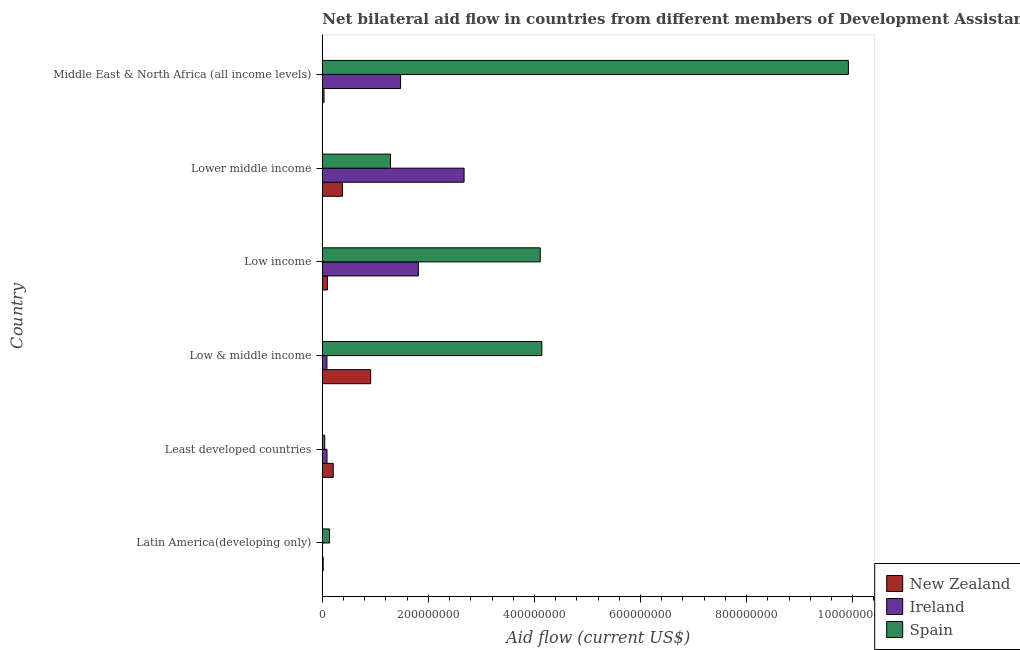How many groups of bars are there?
Offer a terse response. 6. Are the number of bars on each tick of the Y-axis equal?
Give a very brief answer. Yes. What is the label of the 1st group of bars from the top?
Your answer should be compact. Middle East & North Africa (all income levels). What is the amount of aid provided by new zealand in Latin America(developing only)?
Provide a succinct answer. 1.61e+06. Across all countries, what is the maximum amount of aid provided by spain?
Ensure brevity in your answer.  9.92e+08. Across all countries, what is the minimum amount of aid provided by new zealand?
Ensure brevity in your answer.  1.61e+06. In which country was the amount of aid provided by ireland minimum?
Provide a short and direct response. Latin America(developing only). What is the total amount of aid provided by new zealand in the graph?
Your answer should be very brief. 1.64e+08. What is the difference between the amount of aid provided by spain in Latin America(developing only) and that in Low & middle income?
Keep it short and to the point. -4.00e+08. What is the difference between the amount of aid provided by spain in Low & middle income and the amount of aid provided by new zealand in Least developed countries?
Make the answer very short. 3.93e+08. What is the average amount of aid provided by ireland per country?
Keep it short and to the point. 1.02e+08. What is the difference between the amount of aid provided by ireland and amount of aid provided by new zealand in Latin America(developing only)?
Ensure brevity in your answer.  -1.24e+06. In how many countries, is the amount of aid provided by new zealand greater than 800000000 US$?
Provide a succinct answer. 0. What is the ratio of the amount of aid provided by spain in Latin America(developing only) to that in Low income?
Provide a succinct answer. 0.03. Is the amount of aid provided by ireland in Latin America(developing only) less than that in Lower middle income?
Ensure brevity in your answer.  Yes. Is the difference between the amount of aid provided by new zealand in Low income and Middle East & North Africa (all income levels) greater than the difference between the amount of aid provided by ireland in Low income and Middle East & North Africa (all income levels)?
Your answer should be very brief. No. What is the difference between the highest and the second highest amount of aid provided by new zealand?
Make the answer very short. 5.33e+07. What is the difference between the highest and the lowest amount of aid provided by new zealand?
Give a very brief answer. 8.96e+07. In how many countries, is the amount of aid provided by new zealand greater than the average amount of aid provided by new zealand taken over all countries?
Provide a succinct answer. 2. What does the 1st bar from the top in Latin America(developing only) represents?
Make the answer very short. Spain. What does the 3rd bar from the bottom in Latin America(developing only) represents?
Make the answer very short. Spain. How many bars are there?
Make the answer very short. 18. Are all the bars in the graph horizontal?
Your response must be concise. Yes. How many countries are there in the graph?
Your response must be concise. 6. What is the difference between two consecutive major ticks on the X-axis?
Your answer should be compact. 2.00e+08. Are the values on the major ticks of X-axis written in scientific E-notation?
Your answer should be very brief. No. Does the graph contain any zero values?
Your answer should be compact. No. Does the graph contain grids?
Provide a short and direct response. No. How are the legend labels stacked?
Provide a short and direct response. Vertical. What is the title of the graph?
Your answer should be compact. Net bilateral aid flow in countries from different members of Development Assistance Committee. Does "Ages 65 and above" appear as one of the legend labels in the graph?
Make the answer very short. No. What is the Aid flow (current US$) of New Zealand in Latin America(developing only)?
Provide a succinct answer. 1.61e+06. What is the Aid flow (current US$) in Ireland in Latin America(developing only)?
Offer a very short reply. 3.70e+05. What is the Aid flow (current US$) in Spain in Latin America(developing only)?
Provide a succinct answer. 1.36e+07. What is the Aid flow (current US$) in New Zealand in Least developed countries?
Offer a terse response. 2.06e+07. What is the Aid flow (current US$) of Ireland in Least developed countries?
Offer a very short reply. 8.82e+06. What is the Aid flow (current US$) in Spain in Least developed countries?
Provide a succinct answer. 4.51e+06. What is the Aid flow (current US$) in New Zealand in Low & middle income?
Ensure brevity in your answer.  9.12e+07. What is the Aid flow (current US$) in Ireland in Low & middle income?
Offer a very short reply. 8.66e+06. What is the Aid flow (current US$) of Spain in Low & middle income?
Provide a succinct answer. 4.14e+08. What is the Aid flow (current US$) in New Zealand in Low income?
Offer a very short reply. 9.64e+06. What is the Aid flow (current US$) of Ireland in Low income?
Give a very brief answer. 1.81e+08. What is the Aid flow (current US$) of Spain in Low income?
Give a very brief answer. 4.11e+08. What is the Aid flow (current US$) of New Zealand in Lower middle income?
Ensure brevity in your answer.  3.79e+07. What is the Aid flow (current US$) of Ireland in Lower middle income?
Provide a succinct answer. 2.67e+08. What is the Aid flow (current US$) in Spain in Lower middle income?
Provide a succinct answer. 1.29e+08. What is the Aid flow (current US$) of New Zealand in Middle East & North Africa (all income levels)?
Offer a very short reply. 3.16e+06. What is the Aid flow (current US$) in Ireland in Middle East & North Africa (all income levels)?
Offer a terse response. 1.48e+08. What is the Aid flow (current US$) in Spain in Middle East & North Africa (all income levels)?
Provide a short and direct response. 9.92e+08. Across all countries, what is the maximum Aid flow (current US$) of New Zealand?
Give a very brief answer. 9.12e+07. Across all countries, what is the maximum Aid flow (current US$) of Ireland?
Your answer should be compact. 2.67e+08. Across all countries, what is the maximum Aid flow (current US$) in Spain?
Offer a terse response. 9.92e+08. Across all countries, what is the minimum Aid flow (current US$) of New Zealand?
Offer a very short reply. 1.61e+06. Across all countries, what is the minimum Aid flow (current US$) in Spain?
Offer a terse response. 4.51e+06. What is the total Aid flow (current US$) in New Zealand in the graph?
Make the answer very short. 1.64e+08. What is the total Aid flow (current US$) of Ireland in the graph?
Ensure brevity in your answer.  6.14e+08. What is the total Aid flow (current US$) in Spain in the graph?
Your answer should be compact. 1.96e+09. What is the difference between the Aid flow (current US$) of New Zealand in Latin America(developing only) and that in Least developed countries?
Your response must be concise. -1.90e+07. What is the difference between the Aid flow (current US$) of Ireland in Latin America(developing only) and that in Least developed countries?
Make the answer very short. -8.45e+06. What is the difference between the Aid flow (current US$) of Spain in Latin America(developing only) and that in Least developed countries?
Your answer should be compact. 9.06e+06. What is the difference between the Aid flow (current US$) in New Zealand in Latin America(developing only) and that in Low & middle income?
Keep it short and to the point. -8.96e+07. What is the difference between the Aid flow (current US$) of Ireland in Latin America(developing only) and that in Low & middle income?
Ensure brevity in your answer.  -8.29e+06. What is the difference between the Aid flow (current US$) in Spain in Latin America(developing only) and that in Low & middle income?
Provide a short and direct response. -4.00e+08. What is the difference between the Aid flow (current US$) in New Zealand in Latin America(developing only) and that in Low income?
Make the answer very short. -8.03e+06. What is the difference between the Aid flow (current US$) in Ireland in Latin America(developing only) and that in Low income?
Offer a very short reply. -1.81e+08. What is the difference between the Aid flow (current US$) in Spain in Latin America(developing only) and that in Low income?
Ensure brevity in your answer.  -3.97e+08. What is the difference between the Aid flow (current US$) of New Zealand in Latin America(developing only) and that in Lower middle income?
Provide a succinct answer. -3.63e+07. What is the difference between the Aid flow (current US$) of Ireland in Latin America(developing only) and that in Lower middle income?
Offer a terse response. -2.67e+08. What is the difference between the Aid flow (current US$) in Spain in Latin America(developing only) and that in Lower middle income?
Keep it short and to the point. -1.15e+08. What is the difference between the Aid flow (current US$) in New Zealand in Latin America(developing only) and that in Middle East & North Africa (all income levels)?
Give a very brief answer. -1.55e+06. What is the difference between the Aid flow (current US$) in Ireland in Latin America(developing only) and that in Middle East & North Africa (all income levels)?
Offer a very short reply. -1.47e+08. What is the difference between the Aid flow (current US$) of Spain in Latin America(developing only) and that in Middle East & North Africa (all income levels)?
Your answer should be very brief. -9.78e+08. What is the difference between the Aid flow (current US$) of New Zealand in Least developed countries and that in Low & middle income?
Your response must be concise. -7.06e+07. What is the difference between the Aid flow (current US$) in Ireland in Least developed countries and that in Low & middle income?
Offer a terse response. 1.60e+05. What is the difference between the Aid flow (current US$) of Spain in Least developed countries and that in Low & middle income?
Give a very brief answer. -4.09e+08. What is the difference between the Aid flow (current US$) in New Zealand in Least developed countries and that in Low income?
Your response must be concise. 1.10e+07. What is the difference between the Aid flow (current US$) in Ireland in Least developed countries and that in Low income?
Your response must be concise. -1.72e+08. What is the difference between the Aid flow (current US$) in Spain in Least developed countries and that in Low income?
Provide a succinct answer. -4.06e+08. What is the difference between the Aid flow (current US$) of New Zealand in Least developed countries and that in Lower middle income?
Provide a short and direct response. -1.73e+07. What is the difference between the Aid flow (current US$) of Ireland in Least developed countries and that in Lower middle income?
Your response must be concise. -2.58e+08. What is the difference between the Aid flow (current US$) in Spain in Least developed countries and that in Lower middle income?
Make the answer very short. -1.24e+08. What is the difference between the Aid flow (current US$) in New Zealand in Least developed countries and that in Middle East & North Africa (all income levels)?
Keep it short and to the point. 1.74e+07. What is the difference between the Aid flow (current US$) of Ireland in Least developed countries and that in Middle East & North Africa (all income levels)?
Your answer should be very brief. -1.39e+08. What is the difference between the Aid flow (current US$) of Spain in Least developed countries and that in Middle East & North Africa (all income levels)?
Ensure brevity in your answer.  -9.87e+08. What is the difference between the Aid flow (current US$) of New Zealand in Low & middle income and that in Low income?
Your answer should be very brief. 8.15e+07. What is the difference between the Aid flow (current US$) in Ireland in Low & middle income and that in Low income?
Offer a terse response. -1.72e+08. What is the difference between the Aid flow (current US$) of Spain in Low & middle income and that in Low income?
Offer a terse response. 2.95e+06. What is the difference between the Aid flow (current US$) in New Zealand in Low & middle income and that in Lower middle income?
Provide a succinct answer. 5.33e+07. What is the difference between the Aid flow (current US$) of Ireland in Low & middle income and that in Lower middle income?
Ensure brevity in your answer.  -2.59e+08. What is the difference between the Aid flow (current US$) of Spain in Low & middle income and that in Lower middle income?
Offer a terse response. 2.85e+08. What is the difference between the Aid flow (current US$) in New Zealand in Low & middle income and that in Middle East & North Africa (all income levels)?
Provide a succinct answer. 8.80e+07. What is the difference between the Aid flow (current US$) in Ireland in Low & middle income and that in Middle East & North Africa (all income levels)?
Keep it short and to the point. -1.39e+08. What is the difference between the Aid flow (current US$) of Spain in Low & middle income and that in Middle East & North Africa (all income levels)?
Provide a succinct answer. -5.78e+08. What is the difference between the Aid flow (current US$) of New Zealand in Low income and that in Lower middle income?
Your answer should be very brief. -2.82e+07. What is the difference between the Aid flow (current US$) in Ireland in Low income and that in Lower middle income?
Keep it short and to the point. -8.62e+07. What is the difference between the Aid flow (current US$) of Spain in Low income and that in Lower middle income?
Offer a very short reply. 2.82e+08. What is the difference between the Aid flow (current US$) in New Zealand in Low income and that in Middle East & North Africa (all income levels)?
Make the answer very short. 6.48e+06. What is the difference between the Aid flow (current US$) in Ireland in Low income and that in Middle East & North Africa (all income levels)?
Ensure brevity in your answer.  3.35e+07. What is the difference between the Aid flow (current US$) in Spain in Low income and that in Middle East & North Africa (all income levels)?
Provide a succinct answer. -5.81e+08. What is the difference between the Aid flow (current US$) in New Zealand in Lower middle income and that in Middle East & North Africa (all income levels)?
Make the answer very short. 3.47e+07. What is the difference between the Aid flow (current US$) of Ireland in Lower middle income and that in Middle East & North Africa (all income levels)?
Offer a terse response. 1.20e+08. What is the difference between the Aid flow (current US$) of Spain in Lower middle income and that in Middle East & North Africa (all income levels)?
Give a very brief answer. -8.63e+08. What is the difference between the Aid flow (current US$) in New Zealand in Latin America(developing only) and the Aid flow (current US$) in Ireland in Least developed countries?
Give a very brief answer. -7.21e+06. What is the difference between the Aid flow (current US$) in New Zealand in Latin America(developing only) and the Aid flow (current US$) in Spain in Least developed countries?
Your response must be concise. -2.90e+06. What is the difference between the Aid flow (current US$) in Ireland in Latin America(developing only) and the Aid flow (current US$) in Spain in Least developed countries?
Your answer should be very brief. -4.14e+06. What is the difference between the Aid flow (current US$) in New Zealand in Latin America(developing only) and the Aid flow (current US$) in Ireland in Low & middle income?
Provide a succinct answer. -7.05e+06. What is the difference between the Aid flow (current US$) of New Zealand in Latin America(developing only) and the Aid flow (current US$) of Spain in Low & middle income?
Offer a very short reply. -4.12e+08. What is the difference between the Aid flow (current US$) in Ireland in Latin America(developing only) and the Aid flow (current US$) in Spain in Low & middle income?
Your answer should be very brief. -4.13e+08. What is the difference between the Aid flow (current US$) in New Zealand in Latin America(developing only) and the Aid flow (current US$) in Ireland in Low income?
Provide a succinct answer. -1.79e+08. What is the difference between the Aid flow (current US$) of New Zealand in Latin America(developing only) and the Aid flow (current US$) of Spain in Low income?
Offer a very short reply. -4.09e+08. What is the difference between the Aid flow (current US$) of Ireland in Latin America(developing only) and the Aid flow (current US$) of Spain in Low income?
Offer a very short reply. -4.11e+08. What is the difference between the Aid flow (current US$) in New Zealand in Latin America(developing only) and the Aid flow (current US$) in Ireland in Lower middle income?
Offer a terse response. -2.66e+08. What is the difference between the Aid flow (current US$) of New Zealand in Latin America(developing only) and the Aid flow (current US$) of Spain in Lower middle income?
Give a very brief answer. -1.27e+08. What is the difference between the Aid flow (current US$) of Ireland in Latin America(developing only) and the Aid flow (current US$) of Spain in Lower middle income?
Provide a short and direct response. -1.28e+08. What is the difference between the Aid flow (current US$) in New Zealand in Latin America(developing only) and the Aid flow (current US$) in Ireland in Middle East & North Africa (all income levels)?
Your answer should be very brief. -1.46e+08. What is the difference between the Aid flow (current US$) in New Zealand in Latin America(developing only) and the Aid flow (current US$) in Spain in Middle East & North Africa (all income levels)?
Your answer should be very brief. -9.90e+08. What is the difference between the Aid flow (current US$) in Ireland in Latin America(developing only) and the Aid flow (current US$) in Spain in Middle East & North Africa (all income levels)?
Your answer should be very brief. -9.92e+08. What is the difference between the Aid flow (current US$) of New Zealand in Least developed countries and the Aid flow (current US$) of Ireland in Low & middle income?
Provide a succinct answer. 1.19e+07. What is the difference between the Aid flow (current US$) in New Zealand in Least developed countries and the Aid flow (current US$) in Spain in Low & middle income?
Give a very brief answer. -3.93e+08. What is the difference between the Aid flow (current US$) in Ireland in Least developed countries and the Aid flow (current US$) in Spain in Low & middle income?
Keep it short and to the point. -4.05e+08. What is the difference between the Aid flow (current US$) in New Zealand in Least developed countries and the Aid flow (current US$) in Ireland in Low income?
Keep it short and to the point. -1.60e+08. What is the difference between the Aid flow (current US$) of New Zealand in Least developed countries and the Aid flow (current US$) of Spain in Low income?
Your answer should be compact. -3.90e+08. What is the difference between the Aid flow (current US$) in Ireland in Least developed countries and the Aid flow (current US$) in Spain in Low income?
Ensure brevity in your answer.  -4.02e+08. What is the difference between the Aid flow (current US$) of New Zealand in Least developed countries and the Aid flow (current US$) of Ireland in Lower middle income?
Ensure brevity in your answer.  -2.47e+08. What is the difference between the Aid flow (current US$) in New Zealand in Least developed countries and the Aid flow (current US$) in Spain in Lower middle income?
Provide a succinct answer. -1.08e+08. What is the difference between the Aid flow (current US$) in Ireland in Least developed countries and the Aid flow (current US$) in Spain in Lower middle income?
Your response must be concise. -1.20e+08. What is the difference between the Aid flow (current US$) of New Zealand in Least developed countries and the Aid flow (current US$) of Ireland in Middle East & North Africa (all income levels)?
Make the answer very short. -1.27e+08. What is the difference between the Aid flow (current US$) in New Zealand in Least developed countries and the Aid flow (current US$) in Spain in Middle East & North Africa (all income levels)?
Keep it short and to the point. -9.71e+08. What is the difference between the Aid flow (current US$) in Ireland in Least developed countries and the Aid flow (current US$) in Spain in Middle East & North Africa (all income levels)?
Keep it short and to the point. -9.83e+08. What is the difference between the Aid flow (current US$) of New Zealand in Low & middle income and the Aid flow (current US$) of Ireland in Low income?
Keep it short and to the point. -8.99e+07. What is the difference between the Aid flow (current US$) of New Zealand in Low & middle income and the Aid flow (current US$) of Spain in Low income?
Your response must be concise. -3.20e+08. What is the difference between the Aid flow (current US$) in Ireland in Low & middle income and the Aid flow (current US$) in Spain in Low income?
Provide a succinct answer. -4.02e+08. What is the difference between the Aid flow (current US$) of New Zealand in Low & middle income and the Aid flow (current US$) of Ireland in Lower middle income?
Keep it short and to the point. -1.76e+08. What is the difference between the Aid flow (current US$) of New Zealand in Low & middle income and the Aid flow (current US$) of Spain in Lower middle income?
Provide a succinct answer. -3.74e+07. What is the difference between the Aid flow (current US$) of Ireland in Low & middle income and the Aid flow (current US$) of Spain in Lower middle income?
Your response must be concise. -1.20e+08. What is the difference between the Aid flow (current US$) in New Zealand in Low & middle income and the Aid flow (current US$) in Ireland in Middle East & North Africa (all income levels)?
Give a very brief answer. -5.64e+07. What is the difference between the Aid flow (current US$) of New Zealand in Low & middle income and the Aid flow (current US$) of Spain in Middle East & North Africa (all income levels)?
Provide a short and direct response. -9.01e+08. What is the difference between the Aid flow (current US$) of Ireland in Low & middle income and the Aid flow (current US$) of Spain in Middle East & North Africa (all income levels)?
Provide a succinct answer. -9.83e+08. What is the difference between the Aid flow (current US$) in New Zealand in Low income and the Aid flow (current US$) in Ireland in Lower middle income?
Your response must be concise. -2.58e+08. What is the difference between the Aid flow (current US$) in New Zealand in Low income and the Aid flow (current US$) in Spain in Lower middle income?
Provide a succinct answer. -1.19e+08. What is the difference between the Aid flow (current US$) of Ireland in Low income and the Aid flow (current US$) of Spain in Lower middle income?
Offer a very short reply. 5.25e+07. What is the difference between the Aid flow (current US$) in New Zealand in Low income and the Aid flow (current US$) in Ireland in Middle East & North Africa (all income levels)?
Provide a succinct answer. -1.38e+08. What is the difference between the Aid flow (current US$) of New Zealand in Low income and the Aid flow (current US$) of Spain in Middle East & North Africa (all income levels)?
Offer a terse response. -9.82e+08. What is the difference between the Aid flow (current US$) of Ireland in Low income and the Aid flow (current US$) of Spain in Middle East & North Africa (all income levels)?
Offer a terse response. -8.11e+08. What is the difference between the Aid flow (current US$) in New Zealand in Lower middle income and the Aid flow (current US$) in Ireland in Middle East & North Africa (all income levels)?
Your answer should be compact. -1.10e+08. What is the difference between the Aid flow (current US$) in New Zealand in Lower middle income and the Aid flow (current US$) in Spain in Middle East & North Africa (all income levels)?
Offer a terse response. -9.54e+08. What is the difference between the Aid flow (current US$) in Ireland in Lower middle income and the Aid flow (current US$) in Spain in Middle East & North Africa (all income levels)?
Your response must be concise. -7.25e+08. What is the average Aid flow (current US$) in New Zealand per country?
Your response must be concise. 2.73e+07. What is the average Aid flow (current US$) in Ireland per country?
Provide a succinct answer. 1.02e+08. What is the average Aid flow (current US$) of Spain per country?
Make the answer very short. 3.27e+08. What is the difference between the Aid flow (current US$) of New Zealand and Aid flow (current US$) of Ireland in Latin America(developing only)?
Offer a very short reply. 1.24e+06. What is the difference between the Aid flow (current US$) in New Zealand and Aid flow (current US$) in Spain in Latin America(developing only)?
Provide a succinct answer. -1.20e+07. What is the difference between the Aid flow (current US$) of Ireland and Aid flow (current US$) of Spain in Latin America(developing only)?
Keep it short and to the point. -1.32e+07. What is the difference between the Aid flow (current US$) in New Zealand and Aid flow (current US$) in Ireland in Least developed countries?
Provide a short and direct response. 1.18e+07. What is the difference between the Aid flow (current US$) in New Zealand and Aid flow (current US$) in Spain in Least developed countries?
Your answer should be compact. 1.61e+07. What is the difference between the Aid flow (current US$) in Ireland and Aid flow (current US$) in Spain in Least developed countries?
Your answer should be very brief. 4.31e+06. What is the difference between the Aid flow (current US$) in New Zealand and Aid flow (current US$) in Ireland in Low & middle income?
Your answer should be very brief. 8.25e+07. What is the difference between the Aid flow (current US$) of New Zealand and Aid flow (current US$) of Spain in Low & middle income?
Provide a succinct answer. -3.23e+08. What is the difference between the Aid flow (current US$) in Ireland and Aid flow (current US$) in Spain in Low & middle income?
Offer a terse response. -4.05e+08. What is the difference between the Aid flow (current US$) in New Zealand and Aid flow (current US$) in Ireland in Low income?
Offer a terse response. -1.71e+08. What is the difference between the Aid flow (current US$) in New Zealand and Aid flow (current US$) in Spain in Low income?
Your response must be concise. -4.01e+08. What is the difference between the Aid flow (current US$) of Ireland and Aid flow (current US$) of Spain in Low income?
Your answer should be compact. -2.30e+08. What is the difference between the Aid flow (current US$) of New Zealand and Aid flow (current US$) of Ireland in Lower middle income?
Give a very brief answer. -2.29e+08. What is the difference between the Aid flow (current US$) of New Zealand and Aid flow (current US$) of Spain in Lower middle income?
Give a very brief answer. -9.07e+07. What is the difference between the Aid flow (current US$) of Ireland and Aid flow (current US$) of Spain in Lower middle income?
Offer a terse response. 1.39e+08. What is the difference between the Aid flow (current US$) of New Zealand and Aid flow (current US$) of Ireland in Middle East & North Africa (all income levels)?
Keep it short and to the point. -1.44e+08. What is the difference between the Aid flow (current US$) of New Zealand and Aid flow (current US$) of Spain in Middle East & North Africa (all income levels)?
Provide a succinct answer. -9.89e+08. What is the difference between the Aid flow (current US$) in Ireland and Aid flow (current US$) in Spain in Middle East & North Africa (all income levels)?
Your answer should be compact. -8.44e+08. What is the ratio of the Aid flow (current US$) in New Zealand in Latin America(developing only) to that in Least developed countries?
Provide a short and direct response. 0.08. What is the ratio of the Aid flow (current US$) of Ireland in Latin America(developing only) to that in Least developed countries?
Offer a very short reply. 0.04. What is the ratio of the Aid flow (current US$) in Spain in Latin America(developing only) to that in Least developed countries?
Give a very brief answer. 3.01. What is the ratio of the Aid flow (current US$) of New Zealand in Latin America(developing only) to that in Low & middle income?
Give a very brief answer. 0.02. What is the ratio of the Aid flow (current US$) of Ireland in Latin America(developing only) to that in Low & middle income?
Offer a very short reply. 0.04. What is the ratio of the Aid flow (current US$) in Spain in Latin America(developing only) to that in Low & middle income?
Offer a very short reply. 0.03. What is the ratio of the Aid flow (current US$) of New Zealand in Latin America(developing only) to that in Low income?
Ensure brevity in your answer.  0.17. What is the ratio of the Aid flow (current US$) in Ireland in Latin America(developing only) to that in Low income?
Ensure brevity in your answer.  0. What is the ratio of the Aid flow (current US$) in Spain in Latin America(developing only) to that in Low income?
Ensure brevity in your answer.  0.03. What is the ratio of the Aid flow (current US$) in New Zealand in Latin America(developing only) to that in Lower middle income?
Offer a very short reply. 0.04. What is the ratio of the Aid flow (current US$) in Ireland in Latin America(developing only) to that in Lower middle income?
Your answer should be compact. 0. What is the ratio of the Aid flow (current US$) in Spain in Latin America(developing only) to that in Lower middle income?
Your response must be concise. 0.11. What is the ratio of the Aid flow (current US$) of New Zealand in Latin America(developing only) to that in Middle East & North Africa (all income levels)?
Your answer should be very brief. 0.51. What is the ratio of the Aid flow (current US$) of Ireland in Latin America(developing only) to that in Middle East & North Africa (all income levels)?
Give a very brief answer. 0. What is the ratio of the Aid flow (current US$) in Spain in Latin America(developing only) to that in Middle East & North Africa (all income levels)?
Provide a succinct answer. 0.01. What is the ratio of the Aid flow (current US$) of New Zealand in Least developed countries to that in Low & middle income?
Offer a very short reply. 0.23. What is the ratio of the Aid flow (current US$) of Ireland in Least developed countries to that in Low & middle income?
Provide a short and direct response. 1.02. What is the ratio of the Aid flow (current US$) in Spain in Least developed countries to that in Low & middle income?
Ensure brevity in your answer.  0.01. What is the ratio of the Aid flow (current US$) in New Zealand in Least developed countries to that in Low income?
Your answer should be very brief. 2.14. What is the ratio of the Aid flow (current US$) in Ireland in Least developed countries to that in Low income?
Offer a terse response. 0.05. What is the ratio of the Aid flow (current US$) of Spain in Least developed countries to that in Low income?
Give a very brief answer. 0.01. What is the ratio of the Aid flow (current US$) in New Zealand in Least developed countries to that in Lower middle income?
Your answer should be compact. 0.54. What is the ratio of the Aid flow (current US$) in Ireland in Least developed countries to that in Lower middle income?
Your response must be concise. 0.03. What is the ratio of the Aid flow (current US$) of Spain in Least developed countries to that in Lower middle income?
Ensure brevity in your answer.  0.04. What is the ratio of the Aid flow (current US$) in New Zealand in Least developed countries to that in Middle East & North Africa (all income levels)?
Ensure brevity in your answer.  6.52. What is the ratio of the Aid flow (current US$) of Ireland in Least developed countries to that in Middle East & North Africa (all income levels)?
Your response must be concise. 0.06. What is the ratio of the Aid flow (current US$) of Spain in Least developed countries to that in Middle East & North Africa (all income levels)?
Provide a succinct answer. 0. What is the ratio of the Aid flow (current US$) of New Zealand in Low & middle income to that in Low income?
Offer a terse response. 9.46. What is the ratio of the Aid flow (current US$) of Ireland in Low & middle income to that in Low income?
Offer a very short reply. 0.05. What is the ratio of the Aid flow (current US$) in Spain in Low & middle income to that in Low income?
Make the answer very short. 1.01. What is the ratio of the Aid flow (current US$) in New Zealand in Low & middle income to that in Lower middle income?
Ensure brevity in your answer.  2.41. What is the ratio of the Aid flow (current US$) of Ireland in Low & middle income to that in Lower middle income?
Your response must be concise. 0.03. What is the ratio of the Aid flow (current US$) in Spain in Low & middle income to that in Lower middle income?
Your answer should be very brief. 3.22. What is the ratio of the Aid flow (current US$) in New Zealand in Low & middle income to that in Middle East & North Africa (all income levels)?
Your answer should be very brief. 28.85. What is the ratio of the Aid flow (current US$) in Ireland in Low & middle income to that in Middle East & North Africa (all income levels)?
Your answer should be very brief. 0.06. What is the ratio of the Aid flow (current US$) of Spain in Low & middle income to that in Middle East & North Africa (all income levels)?
Your answer should be very brief. 0.42. What is the ratio of the Aid flow (current US$) of New Zealand in Low income to that in Lower middle income?
Your answer should be very brief. 0.25. What is the ratio of the Aid flow (current US$) in Ireland in Low income to that in Lower middle income?
Your answer should be compact. 0.68. What is the ratio of the Aid flow (current US$) of Spain in Low income to that in Lower middle income?
Offer a very short reply. 3.2. What is the ratio of the Aid flow (current US$) of New Zealand in Low income to that in Middle East & North Africa (all income levels)?
Your answer should be very brief. 3.05. What is the ratio of the Aid flow (current US$) of Ireland in Low income to that in Middle East & North Africa (all income levels)?
Give a very brief answer. 1.23. What is the ratio of the Aid flow (current US$) of Spain in Low income to that in Middle East & North Africa (all income levels)?
Offer a very short reply. 0.41. What is the ratio of the Aid flow (current US$) of New Zealand in Lower middle income to that in Middle East & North Africa (all income levels)?
Your answer should be very brief. 11.98. What is the ratio of the Aid flow (current US$) of Ireland in Lower middle income to that in Middle East & North Africa (all income levels)?
Your response must be concise. 1.81. What is the ratio of the Aid flow (current US$) in Spain in Lower middle income to that in Middle East & North Africa (all income levels)?
Your answer should be compact. 0.13. What is the difference between the highest and the second highest Aid flow (current US$) of New Zealand?
Your answer should be compact. 5.33e+07. What is the difference between the highest and the second highest Aid flow (current US$) in Ireland?
Provide a succinct answer. 8.62e+07. What is the difference between the highest and the second highest Aid flow (current US$) in Spain?
Your answer should be compact. 5.78e+08. What is the difference between the highest and the lowest Aid flow (current US$) in New Zealand?
Your response must be concise. 8.96e+07. What is the difference between the highest and the lowest Aid flow (current US$) in Ireland?
Provide a short and direct response. 2.67e+08. What is the difference between the highest and the lowest Aid flow (current US$) of Spain?
Ensure brevity in your answer.  9.87e+08. 